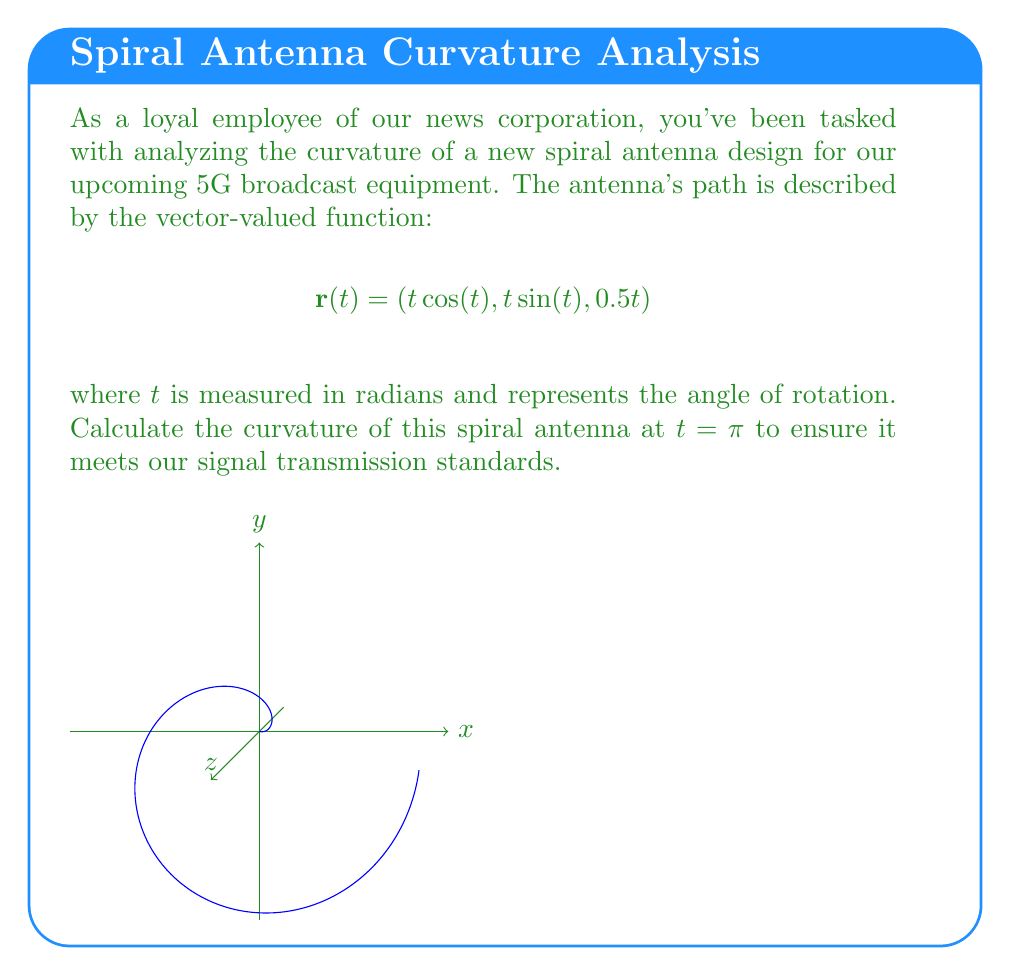What is the answer to this math problem? To calculate the curvature of the spiral antenna, we'll follow these steps:

1) The curvature formula for a vector-valued function is:

   $$\kappa = \frac{|\mathbf{r}'(t) \times \mathbf{r}''(t)|}{|\mathbf{r}'(t)|^3}$$

2) First, let's calculate $\mathbf{r}'(t)$:
   $$\mathbf{r}'(t) = (\cos(t) - t\sin(t), \sin(t) + t\cos(t), 0.5)$$

3) Now, let's calculate $\mathbf{r}''(t)$:
   $$\mathbf{r}''(t) = (-2\sin(t) - t\cos(t), 2\cos(t) - t\sin(t), 0)$$

4) At $t = \pi$:
   $$\mathbf{r}'(\pi) = (-\pi - 1, 0, 0.5)$$
   $$\mathbf{r}''(\pi) = (0, -\pi + 2, 0)$$

5) Calculate the cross product $\mathbf{r}'(\pi) \times \mathbf{r}''(\pi)$:
   $$\mathbf{r}'(\pi) \times \mathbf{r}''(\pi) = (0.5(-\pi+2), 0.5(0), (\pi+1)(-\pi+2))$$
   $$= (0.5(-\pi+2), 0, -\pi^2+\pi+2)$$

6) Calculate $|\mathbf{r}'(\pi) \times \mathbf{r}''(\pi)|$:
   $$|\mathbf{r}'(\pi) \times \mathbf{r}''(\pi)| = \sqrt{(0.5(-\pi+2))^2 + 0^2 + (-\pi^2+\pi+2)^2}$$

7) Calculate $|\mathbf{r}'(\pi)|^3$:
   $$|\mathbf{r}'(\pi)|^3 = ((\pi+1)^2 + 0.25)^{3/2}$$

8) Finally, calculate the curvature:
   $$\kappa = \frac{\sqrt{(0.5(-\pi+2))^2 + (-\pi^2+\pi+2)^2}}{((\pi+1)^2 + 0.25)^{3/2}}$$
Answer: $$\kappa = \frac{\sqrt{(0.5(-\pi+2))^2 + (-\pi^2+\pi+2)^2}}{((\pi+1)^2 + 0.25)^{3/2}}$$ 